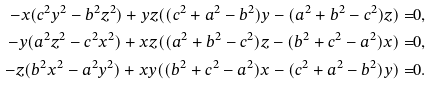Convert formula to latex. <formula><loc_0><loc_0><loc_500><loc_500>- x ( c ^ { 2 } y ^ { 2 } - b ^ { 2 } z ^ { 2 } ) + y z ( ( c ^ { 2 } + a ^ { 2 } - b ^ { 2 } ) y - ( a ^ { 2 } + b ^ { 2 } - c ^ { 2 } ) z ) = & 0 , \\ - y ( a ^ { 2 } z ^ { 2 } - c ^ { 2 } x ^ { 2 } ) + x z ( ( a ^ { 2 } + b ^ { 2 } - c ^ { 2 } ) z - ( b ^ { 2 } + c ^ { 2 } - a ^ { 2 } ) x ) = & 0 , \\ - z ( b ^ { 2 } x ^ { 2 } - a ^ { 2 } y ^ { 2 } ) + x y ( ( b ^ { 2 } + c ^ { 2 } - a ^ { 2 } ) x - ( c ^ { 2 } + a ^ { 2 } - b ^ { 2 } ) y ) = & 0 . \\</formula> 